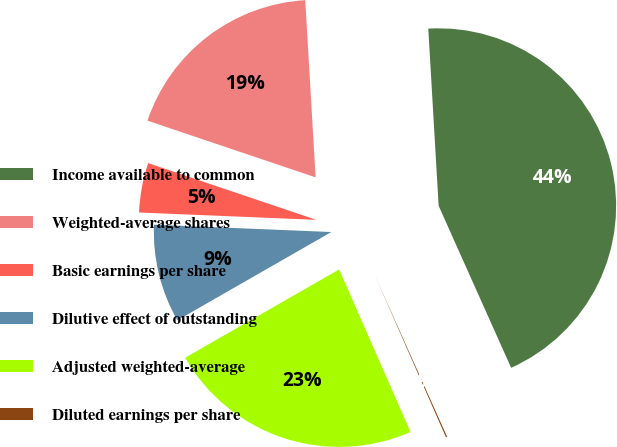Convert chart to OTSL. <chart><loc_0><loc_0><loc_500><loc_500><pie_chart><fcel>Income available to common<fcel>Weighted-average shares<fcel>Basic earnings per share<fcel>Dilutive effect of outstanding<fcel>Adjusted weighted-average<fcel>Diluted earnings per share<nl><fcel>44.23%<fcel>18.89%<fcel>4.52%<fcel>8.94%<fcel>23.3%<fcel>0.11%<nl></chart> 